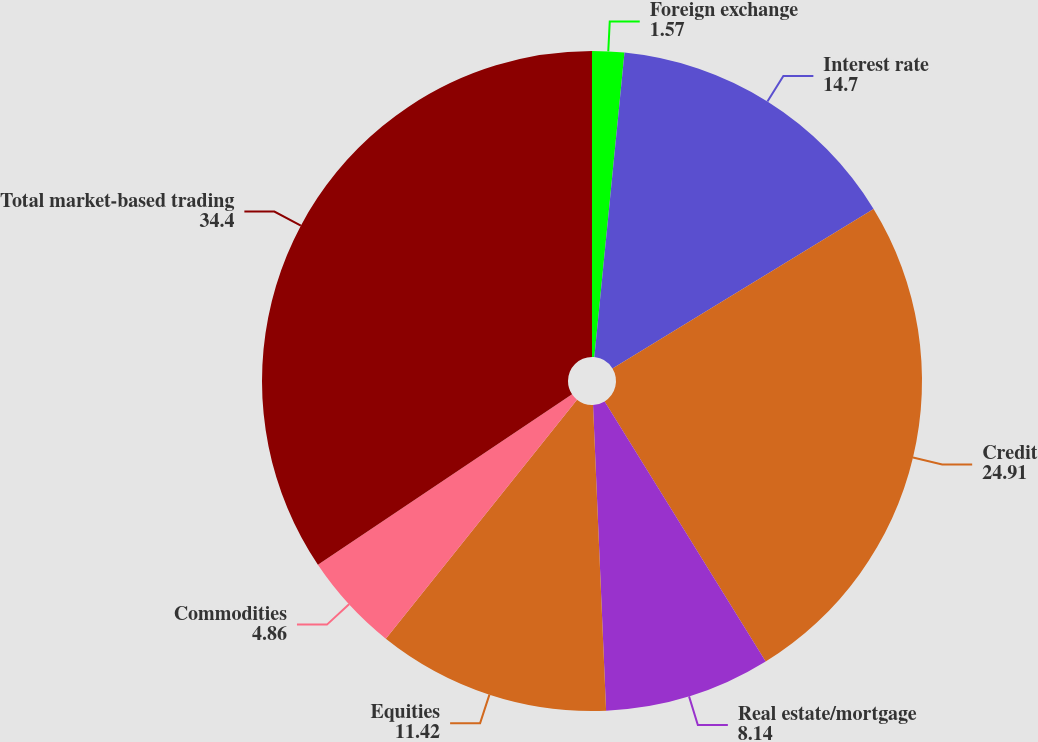<chart> <loc_0><loc_0><loc_500><loc_500><pie_chart><fcel>Foreign exchange<fcel>Interest rate<fcel>Credit<fcel>Real estate/mortgage<fcel>Equities<fcel>Commodities<fcel>Total market-based trading<nl><fcel>1.57%<fcel>14.7%<fcel>24.91%<fcel>8.14%<fcel>11.42%<fcel>4.86%<fcel>34.4%<nl></chart> 